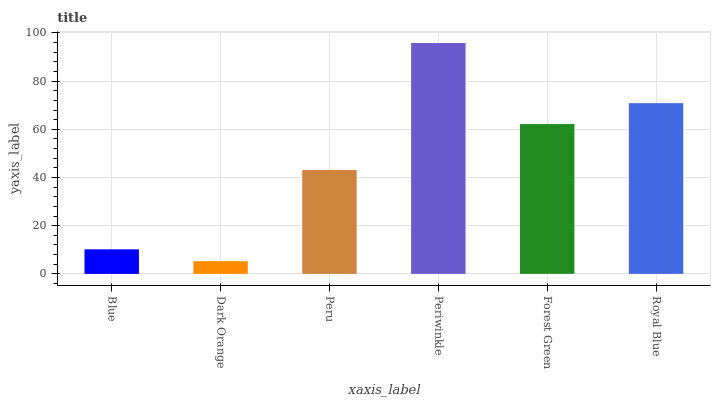Is Dark Orange the minimum?
Answer yes or no. Yes. Is Periwinkle the maximum?
Answer yes or no. Yes. Is Peru the minimum?
Answer yes or no. No. Is Peru the maximum?
Answer yes or no. No. Is Peru greater than Dark Orange?
Answer yes or no. Yes. Is Dark Orange less than Peru?
Answer yes or no. Yes. Is Dark Orange greater than Peru?
Answer yes or no. No. Is Peru less than Dark Orange?
Answer yes or no. No. Is Forest Green the high median?
Answer yes or no. Yes. Is Peru the low median?
Answer yes or no. Yes. Is Blue the high median?
Answer yes or no. No. Is Periwinkle the low median?
Answer yes or no. No. 